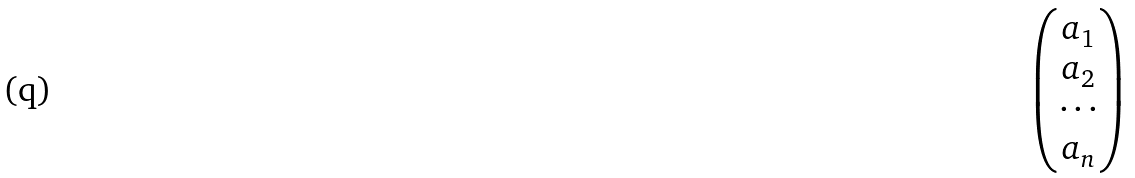Convert formula to latex. <formula><loc_0><loc_0><loc_500><loc_500>\begin{pmatrix} a _ { 1 } \\ a _ { 2 } \\ \cdots \\ a _ { n } \end{pmatrix}</formula> 